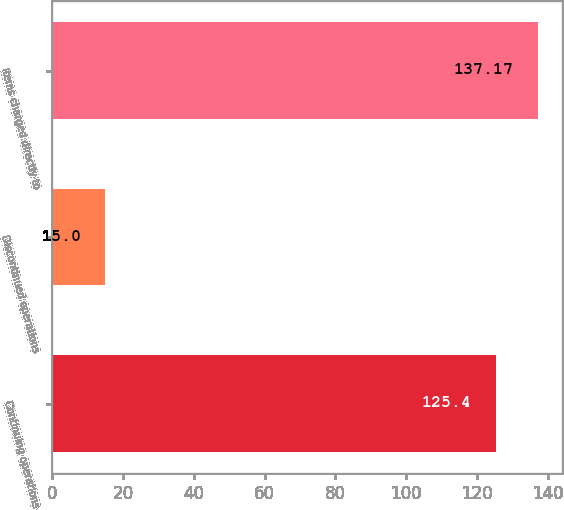Convert chart. <chart><loc_0><loc_0><loc_500><loc_500><bar_chart><fcel>Continuing operations<fcel>Discontinued operations<fcel>Items charged directly to<nl><fcel>125.4<fcel>15<fcel>137.17<nl></chart> 